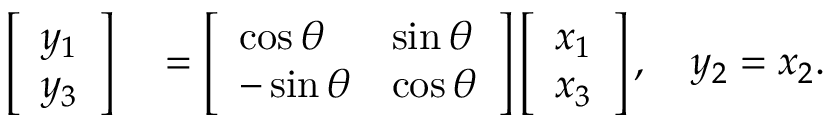Convert formula to latex. <formula><loc_0><loc_0><loc_500><loc_500>\begin{array} { r l } { \left [ \begin{array} { l } { y _ { 1 } } \\ { y _ { 3 } } \end{array} \right ] } & = \left [ \begin{array} { l l } { \cos \theta } & { \sin \theta } \\ { - \sin \theta } & { \cos \theta } \end{array} \right ] \left [ \begin{array} { l } { x _ { 1 } } \\ { x _ { 3 } } \end{array} \right ] , \quad y _ { 2 } = x _ { 2 } . } \end{array}</formula> 